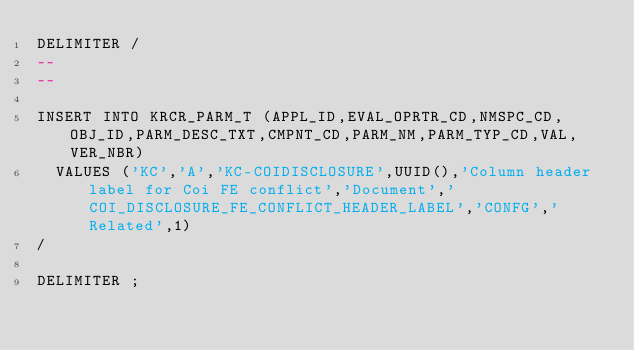<code> <loc_0><loc_0><loc_500><loc_500><_SQL_>DELIMITER /
--
--

INSERT INTO KRCR_PARM_T (APPL_ID,EVAL_OPRTR_CD,NMSPC_CD,OBJ_ID,PARM_DESC_TXT,CMPNT_CD,PARM_NM,PARM_TYP_CD,VAL,VER_NBR)
  VALUES ('KC','A','KC-COIDISCLOSURE',UUID(),'Column header label for Coi FE conflict','Document','COI_DISCLOSURE_FE_CONFLICT_HEADER_LABEL','CONFG','Related',1)
/

DELIMITER ;
</code> 